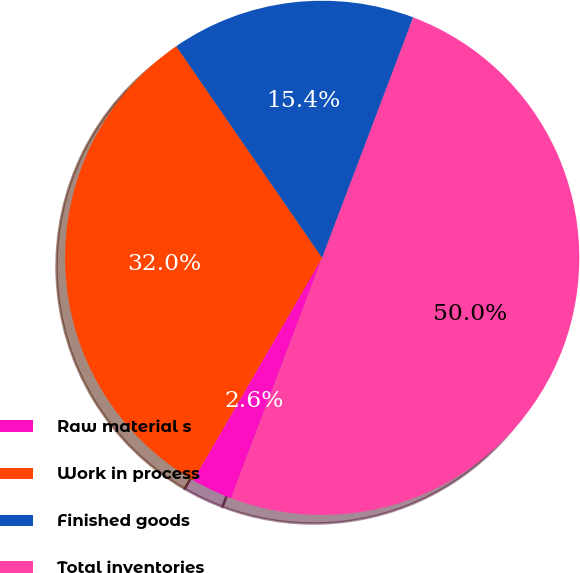Convert chart. <chart><loc_0><loc_0><loc_500><loc_500><pie_chart><fcel>Raw material s<fcel>Work in process<fcel>Finished goods<fcel>Total inventories<nl><fcel>2.6%<fcel>32.03%<fcel>15.37%<fcel>50.0%<nl></chart> 